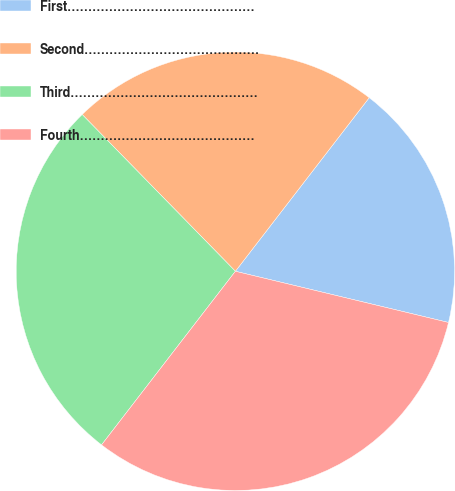<chart> <loc_0><loc_0><loc_500><loc_500><pie_chart><fcel>First………………………………………<fcel>Second……………………………………<fcel>Third………………………………………<fcel>Fourth……………………………………<nl><fcel>18.3%<fcel>22.77%<fcel>27.23%<fcel>31.7%<nl></chart> 